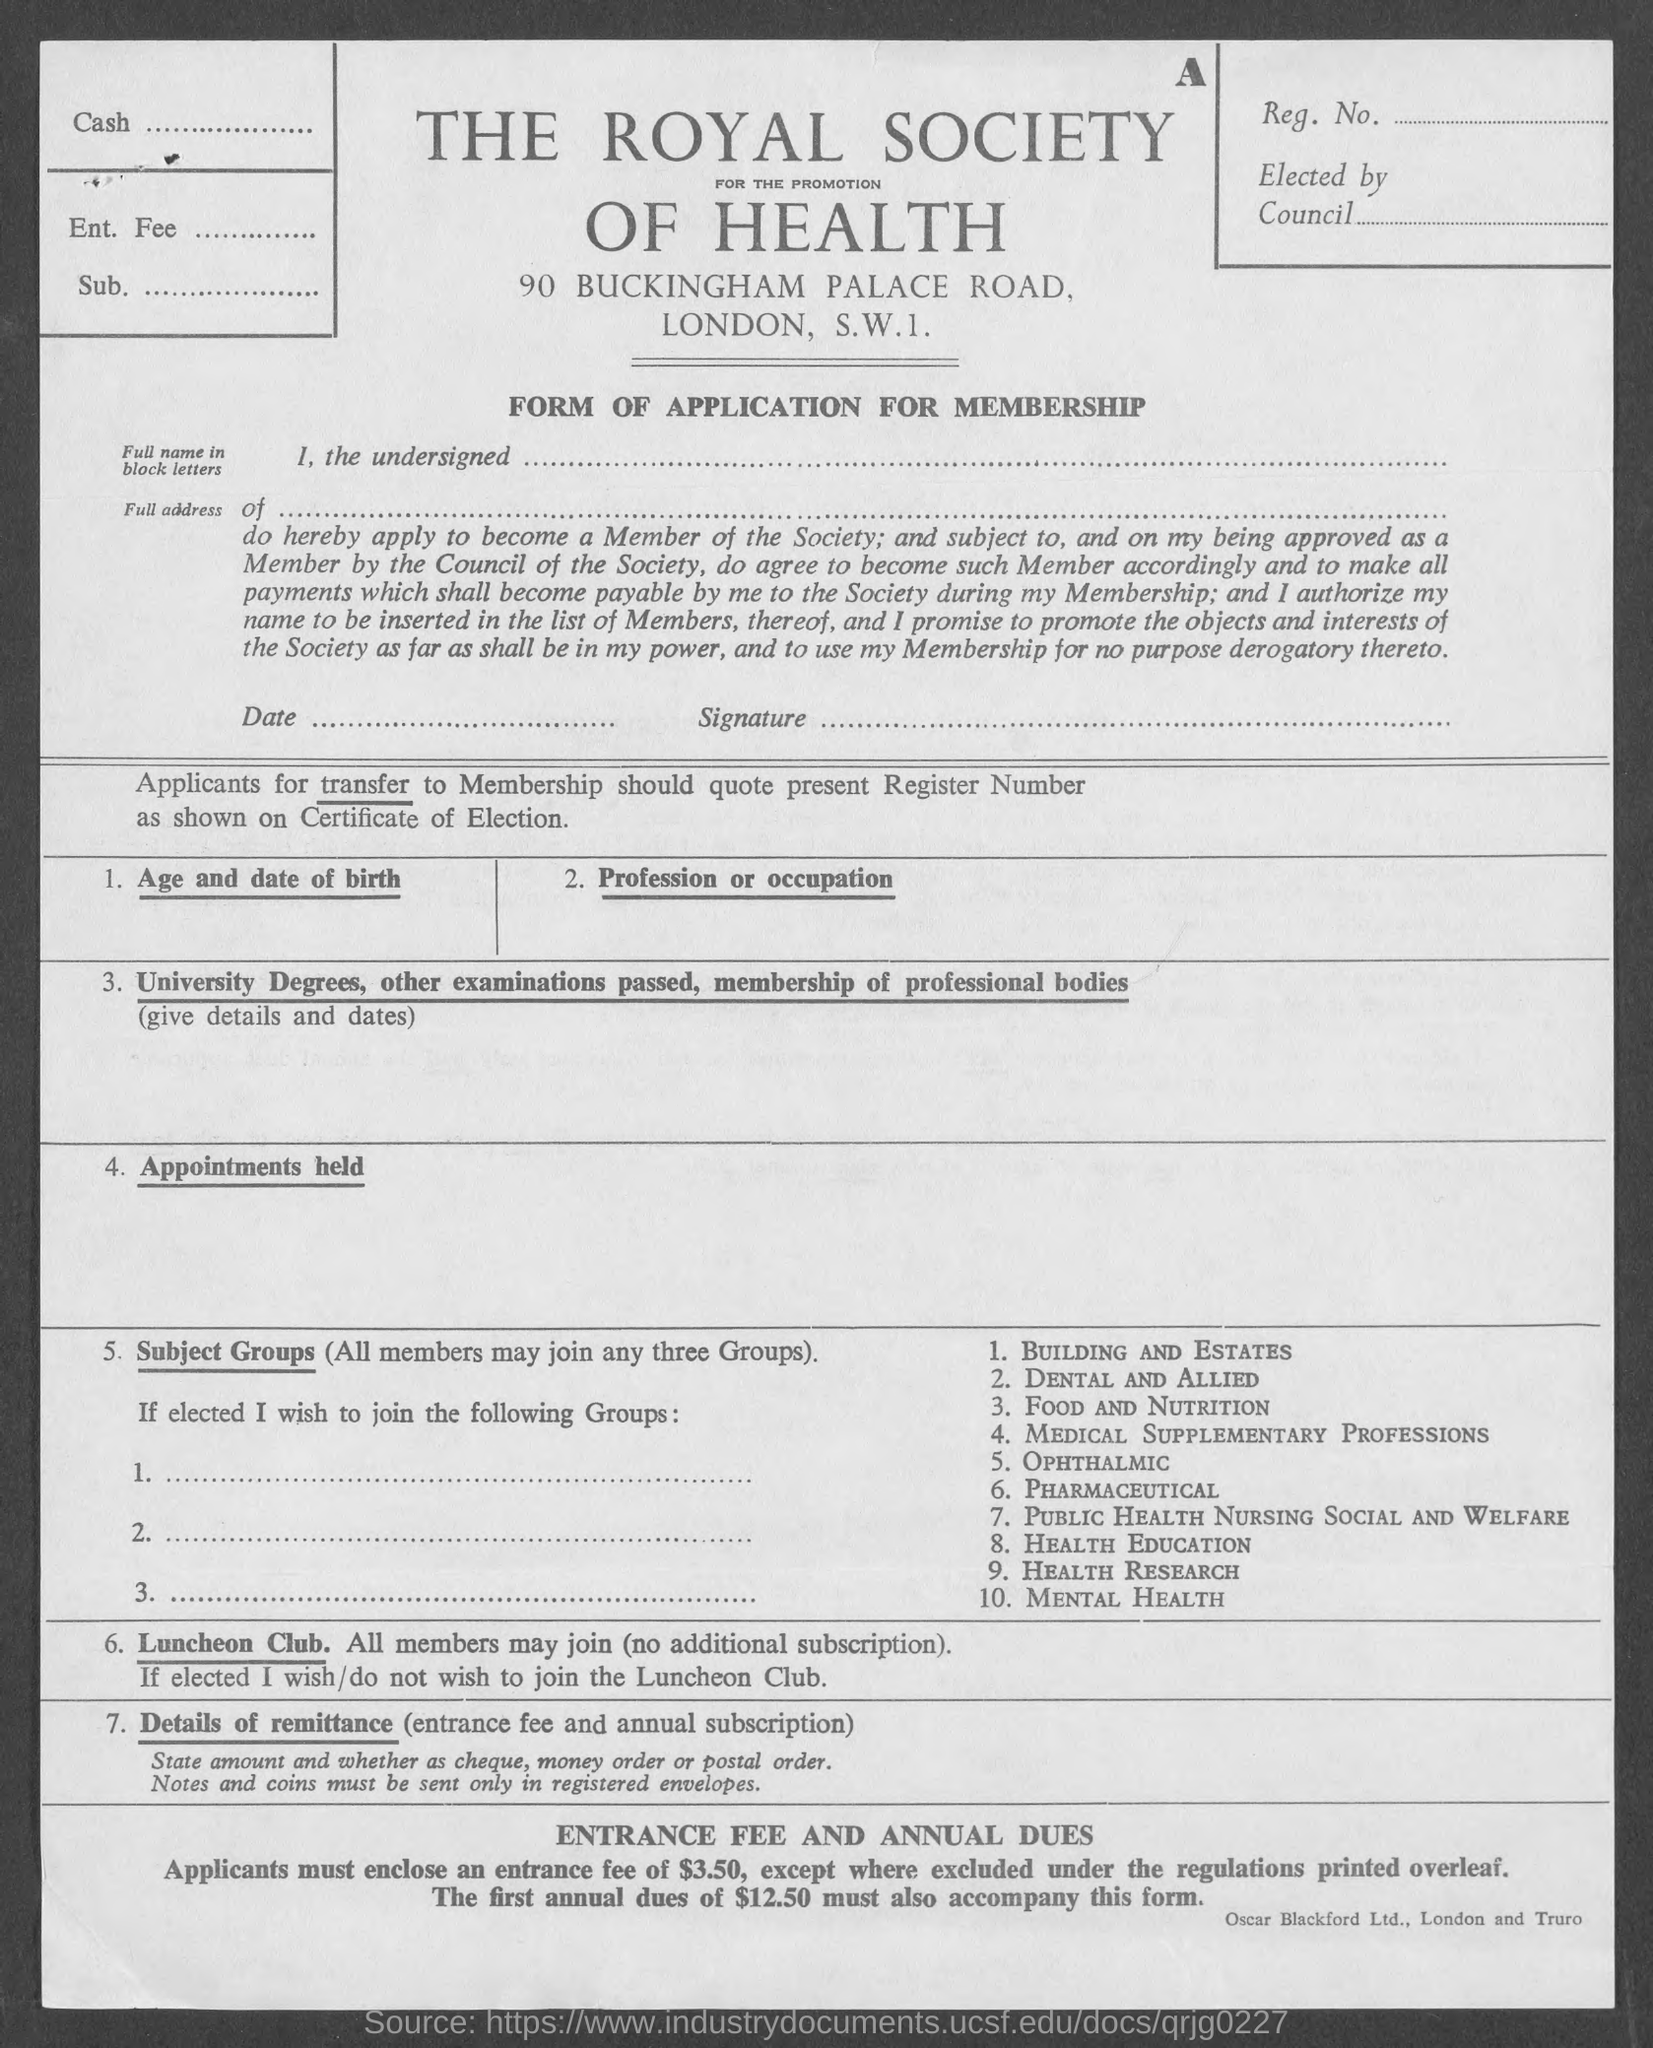Specify some key components in this picture. The form named in the given page is an application for membership. 